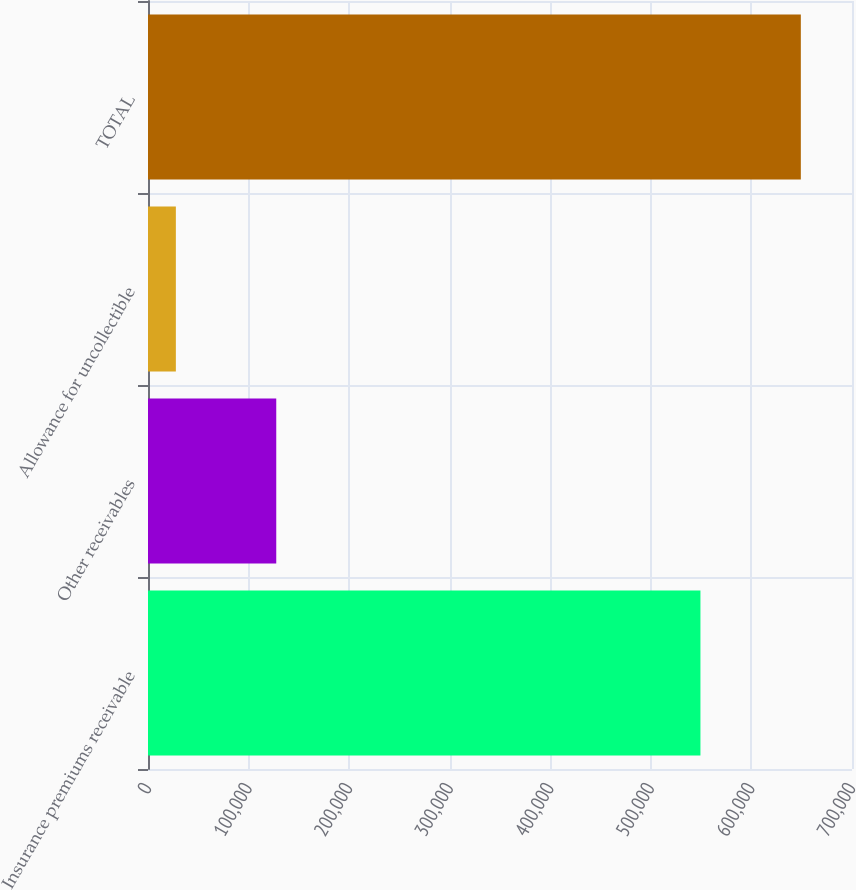Convert chart to OTSL. <chart><loc_0><loc_0><loc_500><loc_500><bar_chart><fcel>Insurance premiums receivable<fcel>Other receivables<fcel>Allowance for uncollectible<fcel>TOTAL<nl><fcel>549301<fcel>127528<fcel>27707<fcel>649122<nl></chart> 